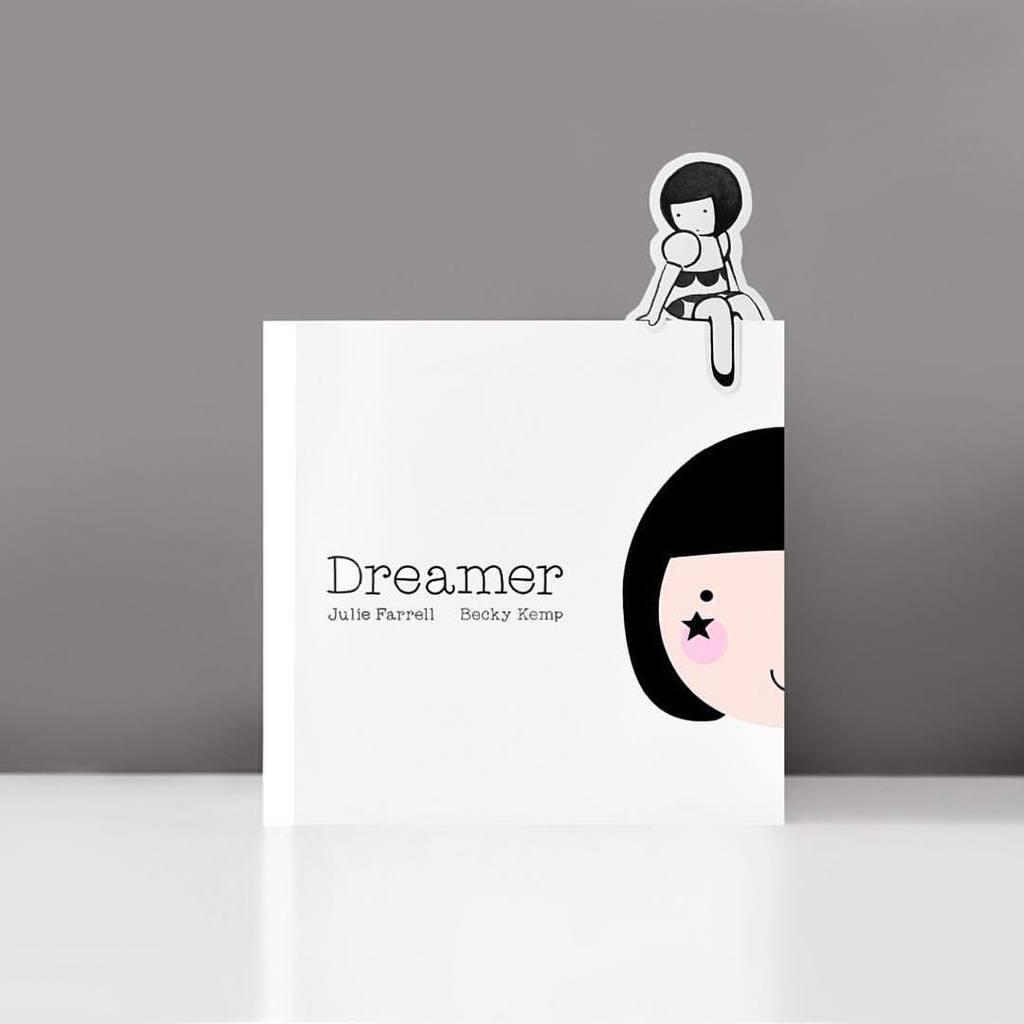What can be found on the image? There is text written on the image, and there is an animated image on the top of the text. Where is the text located in the image? The text is in the front of the image. How many lizards are crawling on the text in the image? There are no lizards present in the image. What wish does the text in the image grant? The image does not grant wishes, as it only contains text and an animated image. 